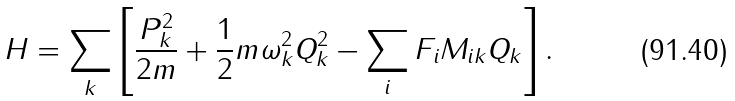Convert formula to latex. <formula><loc_0><loc_0><loc_500><loc_500>H = \sum _ { k } \left [ \frac { P _ { k } ^ { 2 } } { 2 m } + \frac { 1 } { 2 } m \omega _ { k } ^ { 2 } Q _ { k } ^ { 2 } - \sum _ { i } F _ { i } M _ { i k } Q _ { k } \right ] .</formula> 